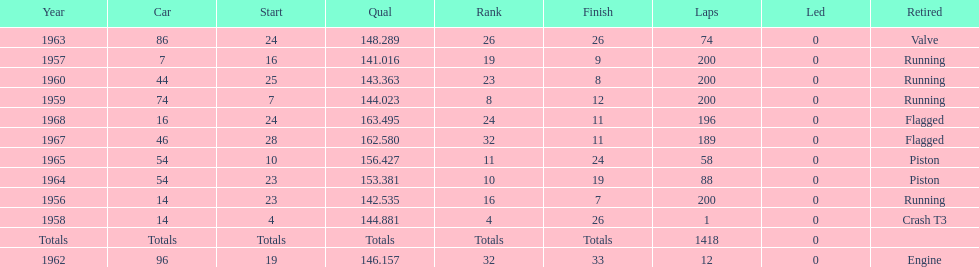Which year is the last qual on the chart 1968. 